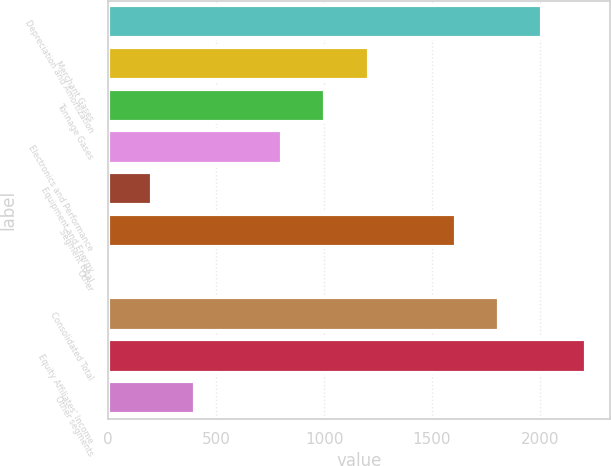Convert chart to OTSL. <chart><loc_0><loc_0><loc_500><loc_500><bar_chart><fcel>Depreciation and Amortization<fcel>Merchant Gases<fcel>Tonnage Gases<fcel>Electronics and Performance<fcel>Equipment and Energy<fcel>Segment total<fcel>Other<fcel>Consolidated Total<fcel>Equity Affiliates' Income<fcel>Other segments<nl><fcel>2011<fcel>1206.84<fcel>1005.8<fcel>804.76<fcel>201.64<fcel>1608.92<fcel>0.6<fcel>1809.96<fcel>2212.04<fcel>402.68<nl></chart> 